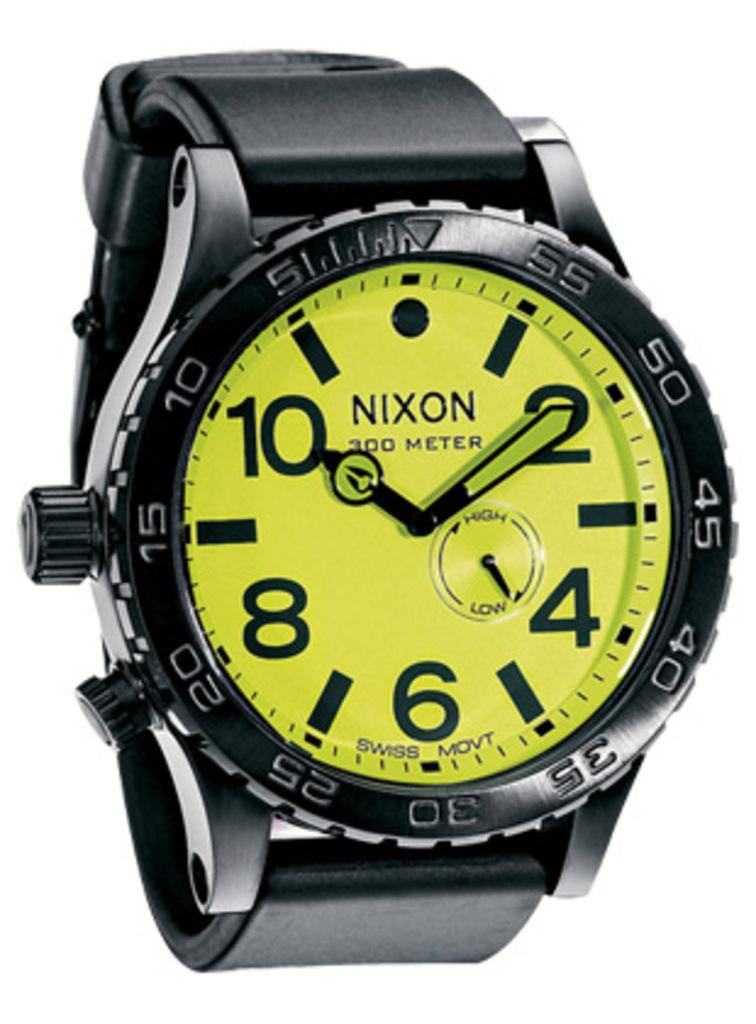What brand of watch?
Offer a terse response. Nixon. How many meters can this watch go?
Your response must be concise. 300. 